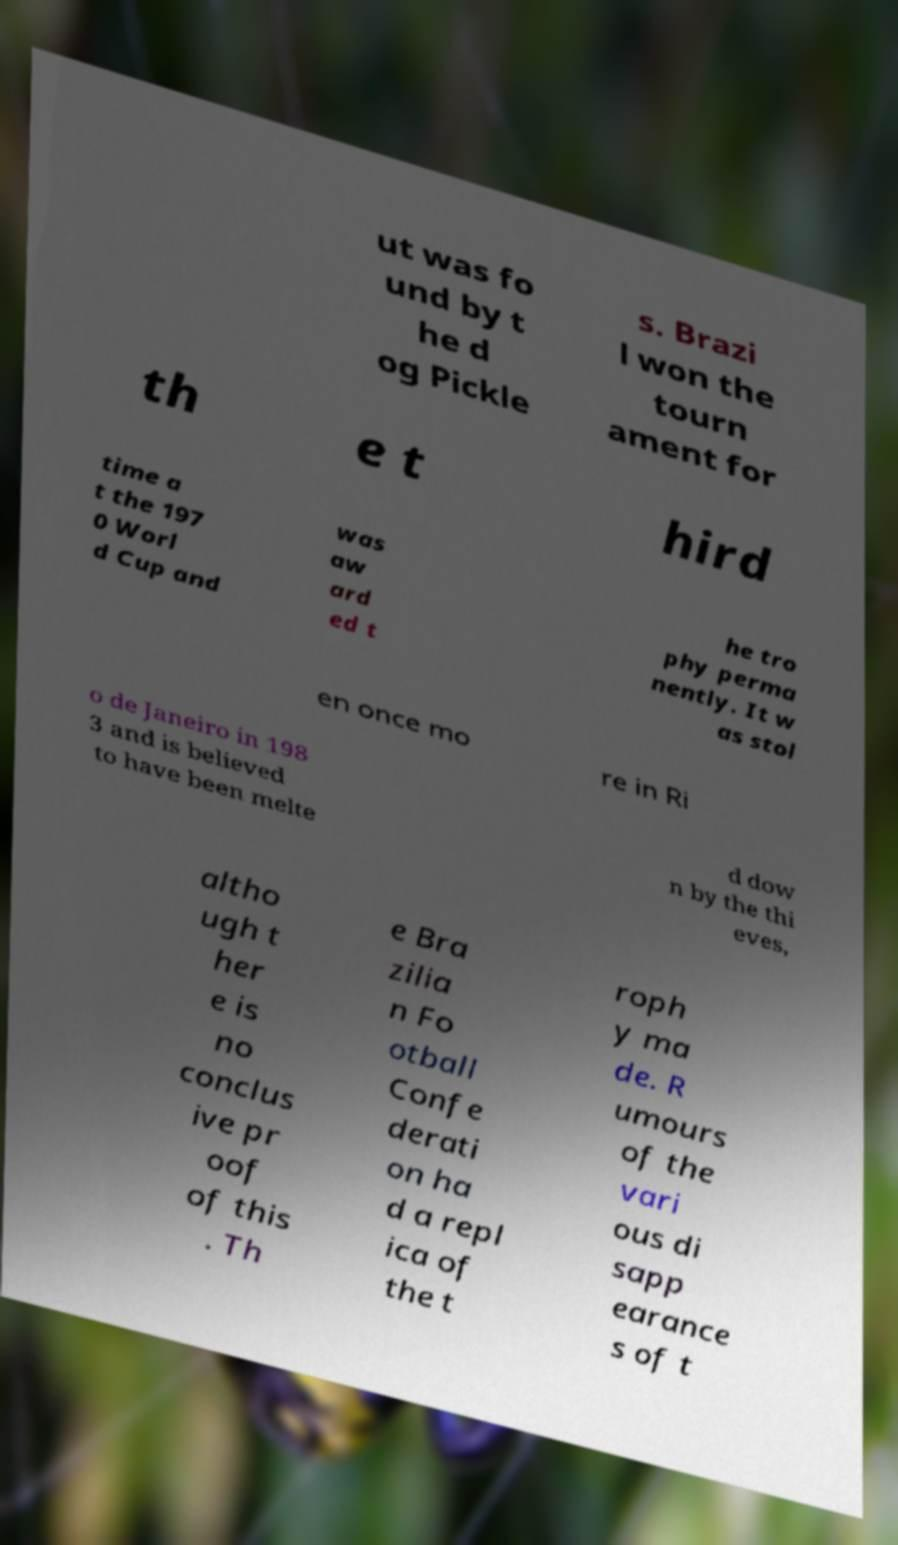Can you read and provide the text displayed in the image?This photo seems to have some interesting text. Can you extract and type it out for me? ut was fo und by t he d og Pickle s. Brazi l won the tourn ament for th e t hird time a t the 197 0 Worl d Cup and was aw ard ed t he tro phy perma nently. It w as stol en once mo re in Ri o de Janeiro in 198 3 and is believed to have been melte d dow n by the thi eves, altho ugh t her e is no conclus ive pr oof of this . Th e Bra zilia n Fo otball Confe derati on ha d a repl ica of the t roph y ma de. R umours of the vari ous di sapp earance s of t 